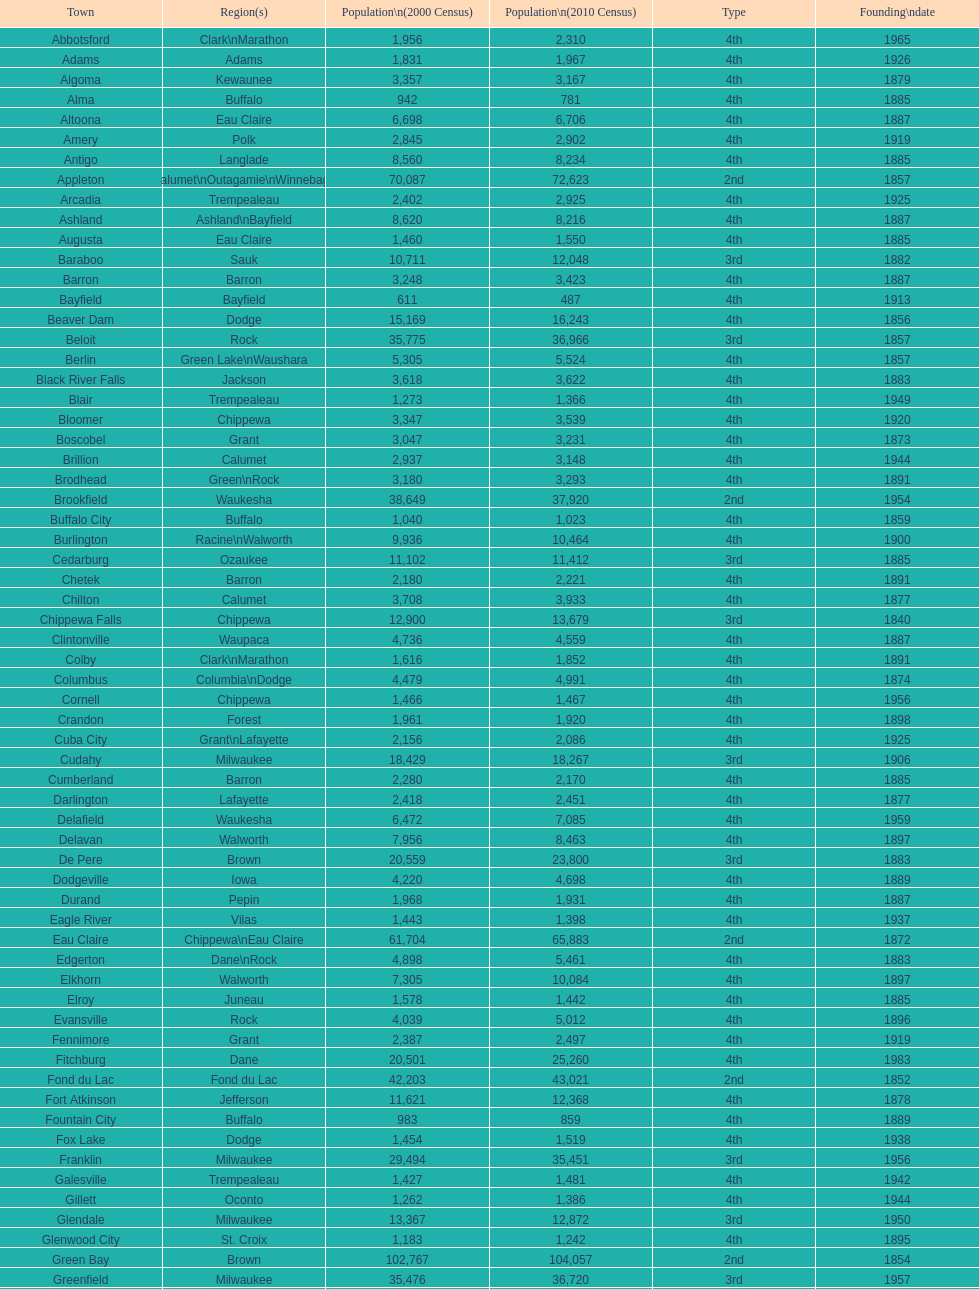Which city in wisconsin is the most populous, based on the 2010 census? Milwaukee. 